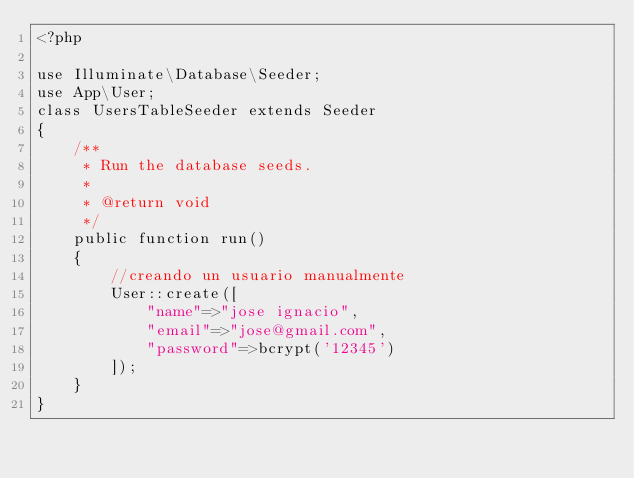Convert code to text. <code><loc_0><loc_0><loc_500><loc_500><_PHP_><?php

use Illuminate\Database\Seeder;
use App\User;
class UsersTableSeeder extends Seeder
{
    /**
     * Run the database seeds.
     *
     * @return void
     */
    public function run()
    {
        //creando un usuario manualmente
        User::create([
            "name"=>"jose ignacio",
            "email"=>"jose@gmail.com",
            "password"=>bcrypt('12345')
        ]);
    }
}
</code> 